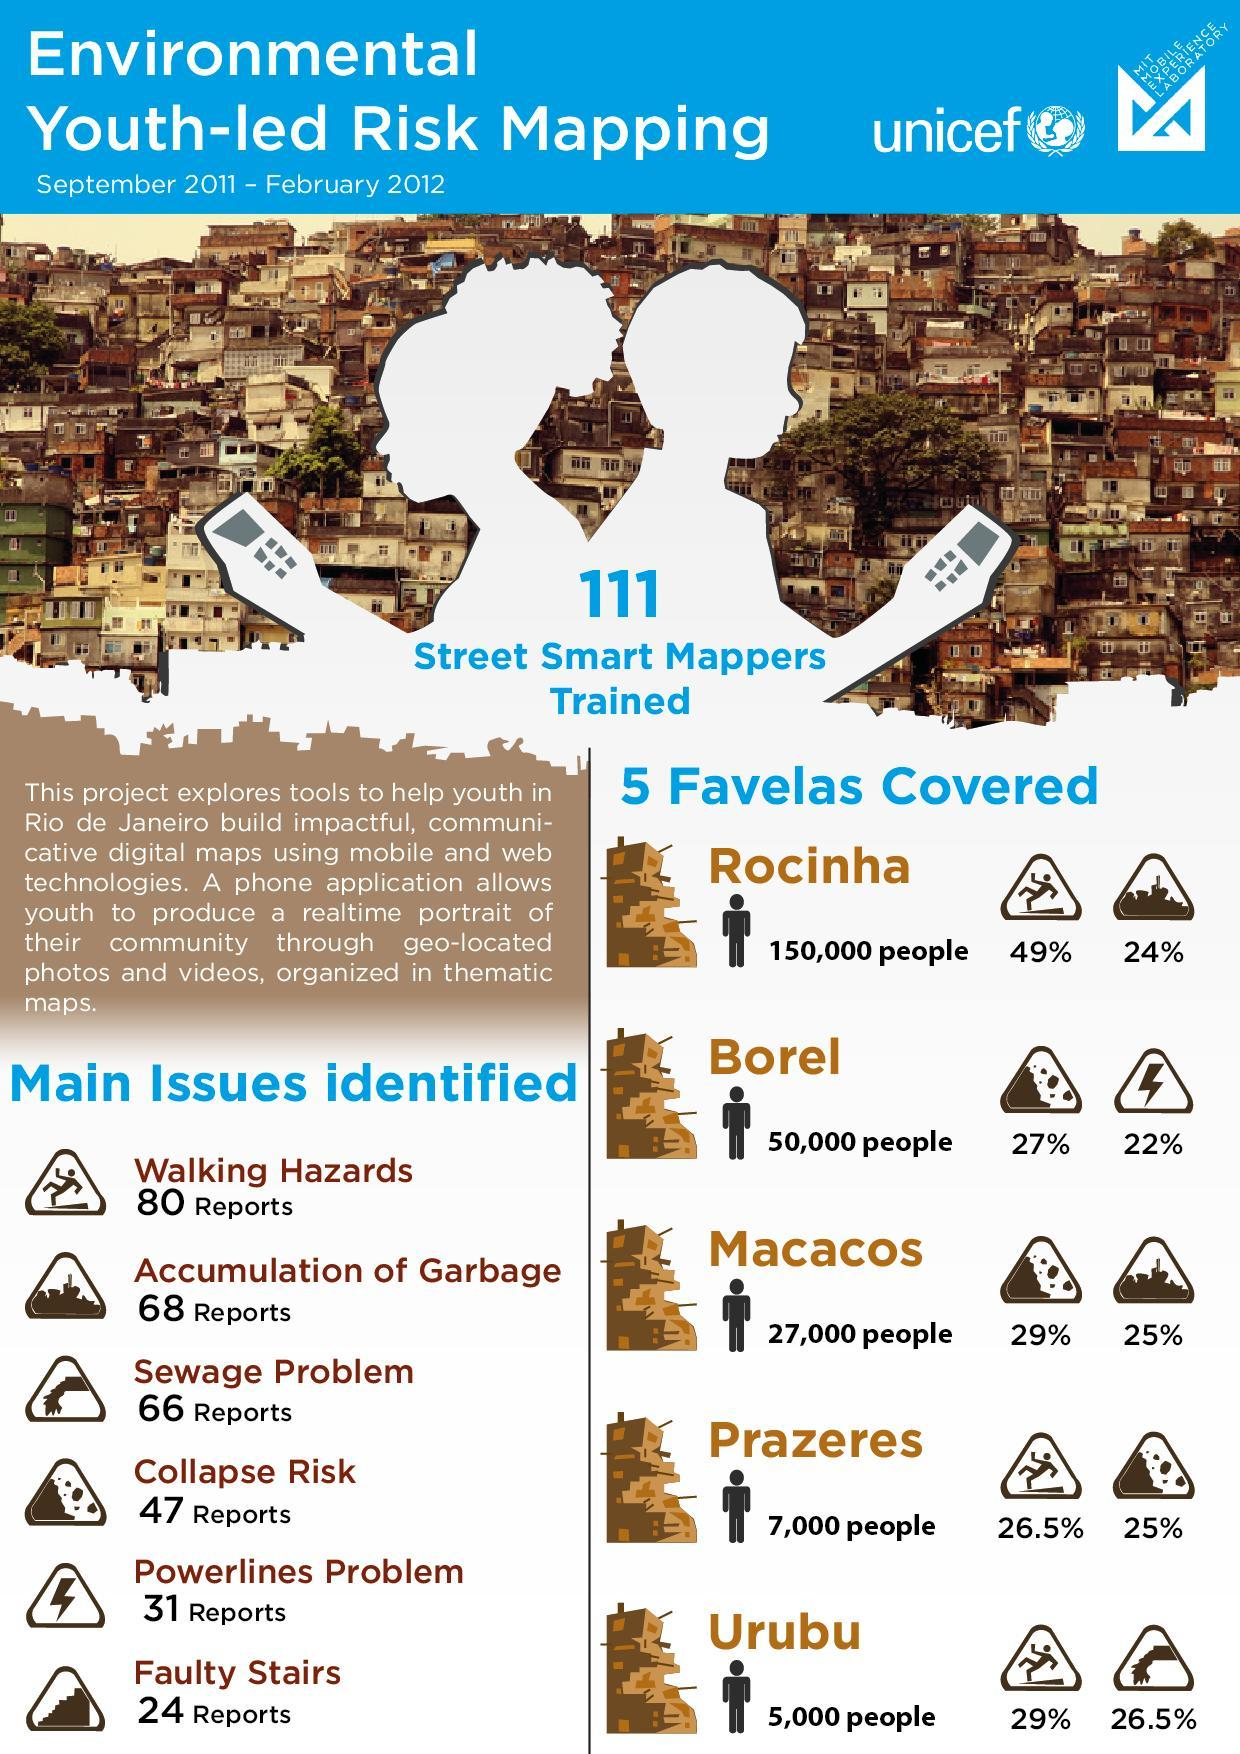What does the sign of a person falling indicate?
Answer the question with a short phrase. Walking Hazards How many cases of sewage and garbage problem were reported? 134 What percent of Borel had powerlines problem? 22% When was the mapping conducted? September 2011 - February 2012 In Prazeres what percentage of reports are of walking hazards? 26.5% Which Favelas have walking hazards? Rocinha, Prazeres, Urubu Which region or favela had 25% collapse risk? Prazeres 